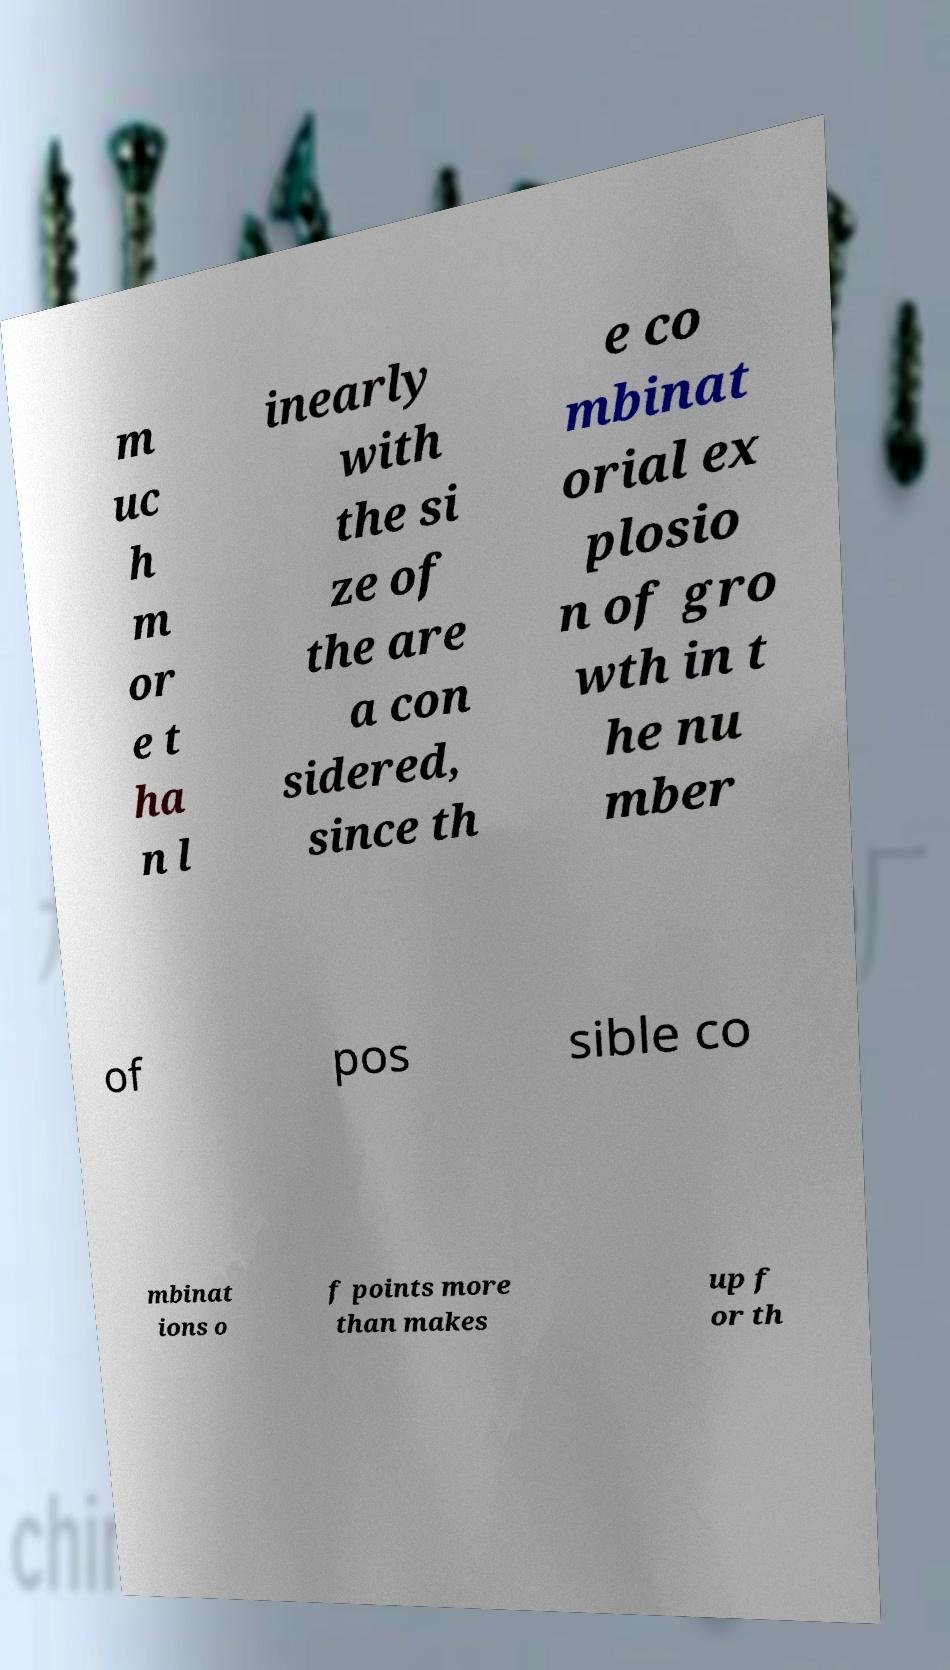Could you assist in decoding the text presented in this image and type it out clearly? m uc h m or e t ha n l inearly with the si ze of the are a con sidered, since th e co mbinat orial ex plosio n of gro wth in t he nu mber of pos sible co mbinat ions o f points more than makes up f or th 